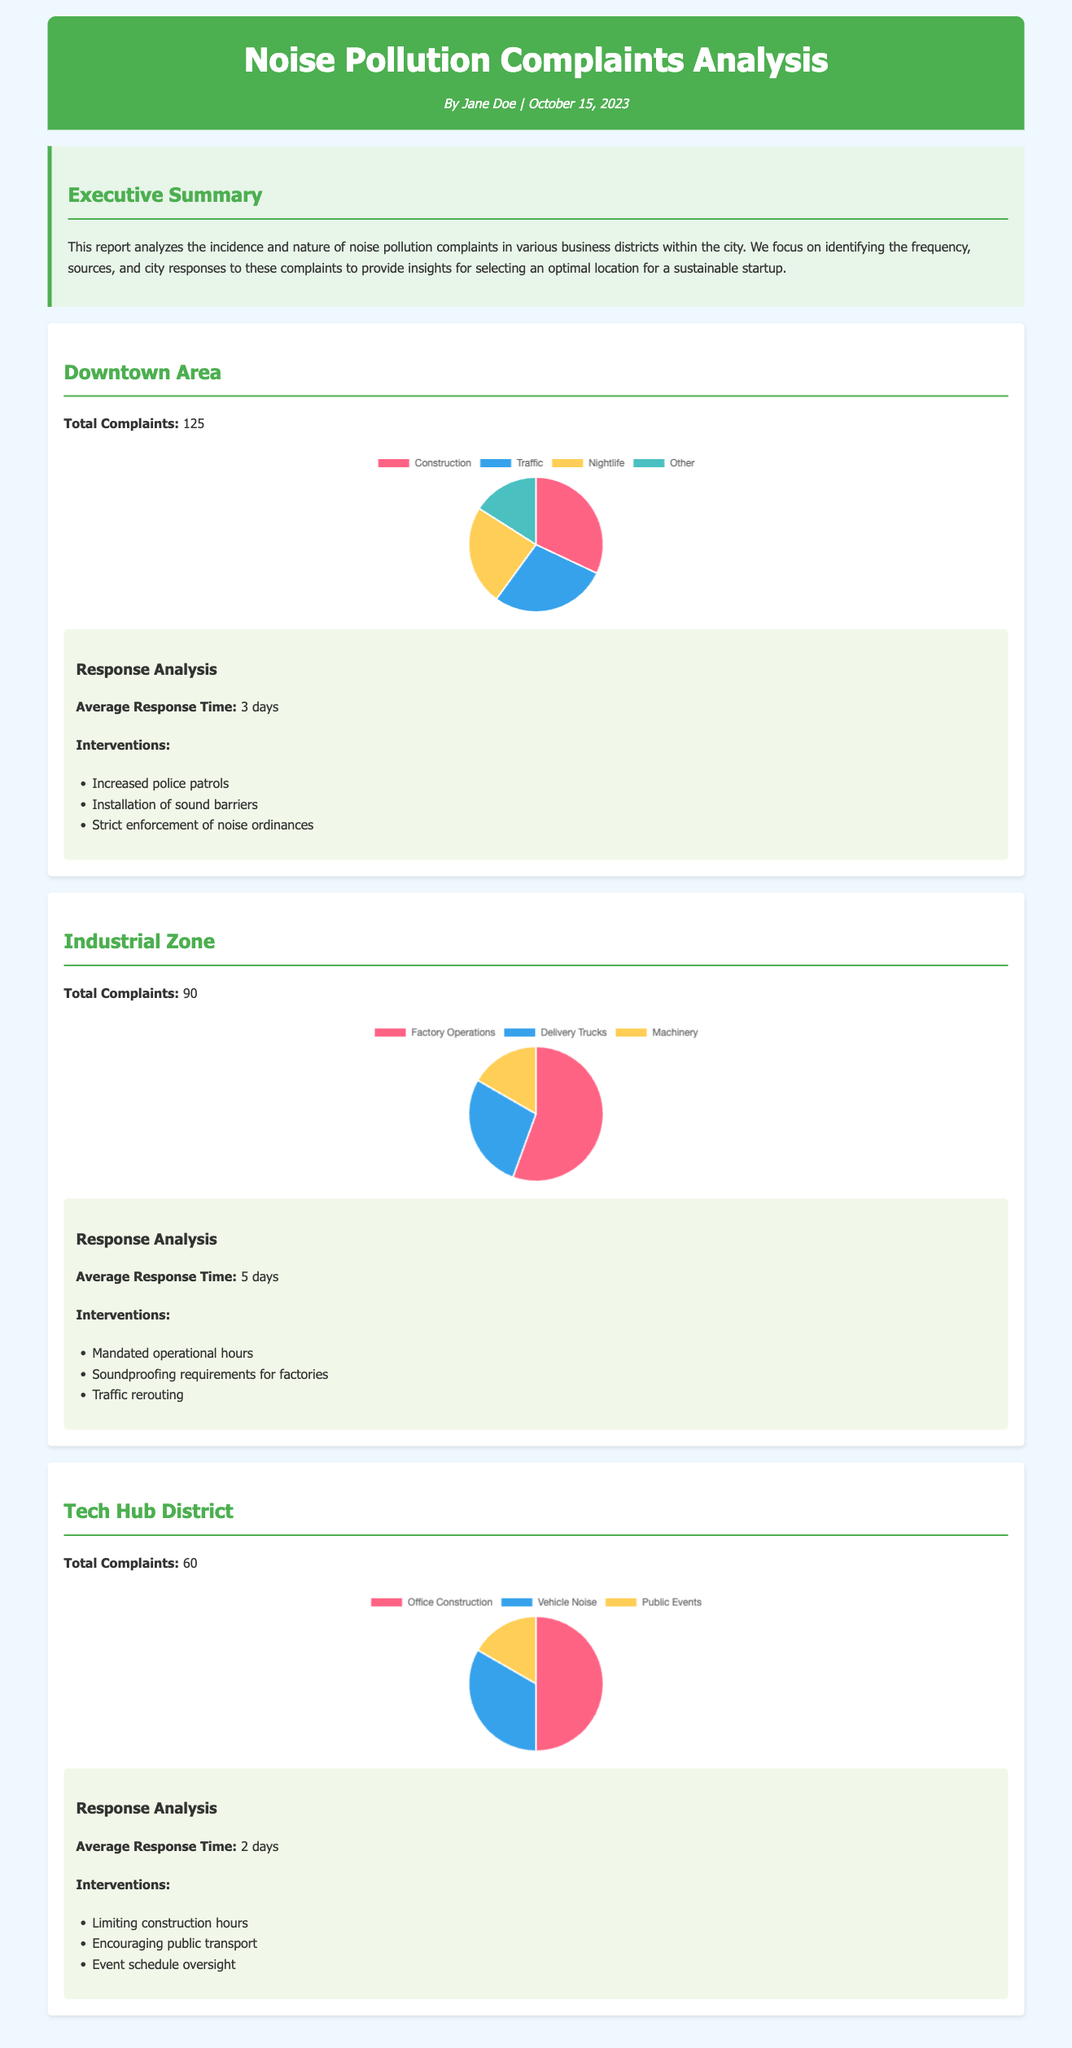What is the total number of complaints in the Downtown Area? The total complaints for the Downtown Area are explicitly stated as 125.
Answer: 125 What is the average response time for the Tech Hub District? The average response time for the Tech Hub District is mentioned as 2 days.
Answer: 2 days What type of interventions were used in the Industrial Zone? The report lists the interventions for the Industrial Zone, which include mandated operational hours, soundproofing requirements, and traffic rerouting.
Answer: Mandated operational hours, soundproofing requirements, traffic rerouting Which district received the highest number of complaints? The Downtown Area has the highest number of complaints at 125, compared to other districts mentioned.
Answer: Downtown Area What are the sources of noise complaints in the Downtown Area? The sources of noise complaints in the Downtown Area include construction, traffic, nightlife, and other categories, with respective data provided in the chart.
Answer: Construction, Traffic, Nightlife, Other 